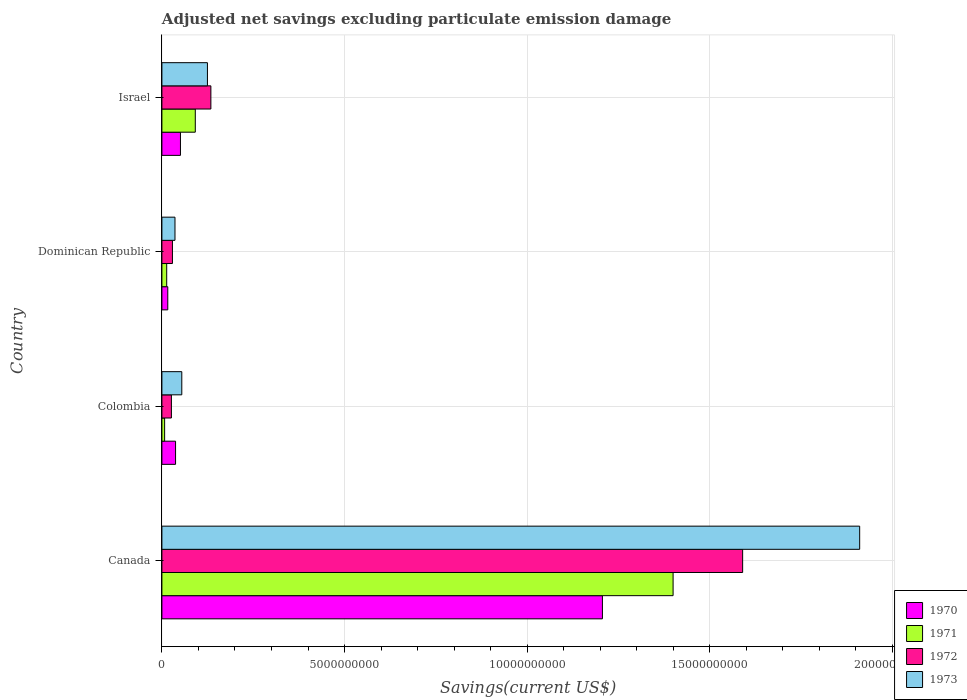How many groups of bars are there?
Provide a succinct answer. 4. Are the number of bars per tick equal to the number of legend labels?
Your answer should be compact. Yes. How many bars are there on the 4th tick from the top?
Offer a very short reply. 4. What is the label of the 2nd group of bars from the top?
Your answer should be compact. Dominican Republic. What is the adjusted net savings in 1971 in Dominican Republic?
Make the answer very short. 1.32e+08. Across all countries, what is the maximum adjusted net savings in 1970?
Provide a short and direct response. 1.21e+1. Across all countries, what is the minimum adjusted net savings in 1972?
Your answer should be very brief. 2.60e+08. In which country was the adjusted net savings in 1970 maximum?
Your response must be concise. Canada. In which country was the adjusted net savings in 1970 minimum?
Provide a succinct answer. Dominican Republic. What is the total adjusted net savings in 1970 in the graph?
Your answer should be very brief. 1.31e+1. What is the difference between the adjusted net savings in 1971 in Colombia and that in Dominican Republic?
Keep it short and to the point. -5.69e+07. What is the difference between the adjusted net savings in 1973 in Dominican Republic and the adjusted net savings in 1972 in Colombia?
Provide a succinct answer. 9.79e+07. What is the average adjusted net savings in 1972 per country?
Offer a very short reply. 4.45e+09. What is the difference between the adjusted net savings in 1970 and adjusted net savings in 1973 in Dominican Republic?
Your answer should be very brief. -1.97e+08. What is the ratio of the adjusted net savings in 1972 in Canada to that in Dominican Republic?
Your answer should be very brief. 55.08. What is the difference between the highest and the second highest adjusted net savings in 1970?
Give a very brief answer. 1.16e+1. What is the difference between the highest and the lowest adjusted net savings in 1970?
Provide a short and direct response. 1.19e+1. Is the sum of the adjusted net savings in 1971 in Colombia and Israel greater than the maximum adjusted net savings in 1972 across all countries?
Your answer should be compact. No. What does the 3rd bar from the top in Canada represents?
Keep it short and to the point. 1971. Is it the case that in every country, the sum of the adjusted net savings in 1973 and adjusted net savings in 1972 is greater than the adjusted net savings in 1971?
Your response must be concise. Yes. How many bars are there?
Make the answer very short. 16. Are the values on the major ticks of X-axis written in scientific E-notation?
Your answer should be very brief. No. Does the graph contain any zero values?
Provide a short and direct response. No. How many legend labels are there?
Provide a succinct answer. 4. What is the title of the graph?
Offer a very short reply. Adjusted net savings excluding particulate emission damage. What is the label or title of the X-axis?
Your answer should be compact. Savings(current US$). What is the label or title of the Y-axis?
Provide a succinct answer. Country. What is the Savings(current US$) of 1970 in Canada?
Provide a succinct answer. 1.21e+1. What is the Savings(current US$) of 1971 in Canada?
Your answer should be compact. 1.40e+1. What is the Savings(current US$) of 1972 in Canada?
Make the answer very short. 1.59e+1. What is the Savings(current US$) of 1973 in Canada?
Keep it short and to the point. 1.91e+1. What is the Savings(current US$) of 1970 in Colombia?
Your response must be concise. 3.74e+08. What is the Savings(current US$) of 1971 in Colombia?
Provide a succinct answer. 7.46e+07. What is the Savings(current US$) of 1972 in Colombia?
Your answer should be very brief. 2.60e+08. What is the Savings(current US$) in 1973 in Colombia?
Your answer should be very brief. 5.45e+08. What is the Savings(current US$) of 1970 in Dominican Republic?
Your response must be concise. 1.61e+08. What is the Savings(current US$) in 1971 in Dominican Republic?
Your response must be concise. 1.32e+08. What is the Savings(current US$) in 1972 in Dominican Republic?
Provide a short and direct response. 2.89e+08. What is the Savings(current US$) of 1973 in Dominican Republic?
Give a very brief answer. 3.58e+08. What is the Savings(current US$) of 1970 in Israel?
Provide a short and direct response. 5.08e+08. What is the Savings(current US$) of 1971 in Israel?
Offer a very short reply. 9.14e+08. What is the Savings(current US$) in 1972 in Israel?
Offer a terse response. 1.34e+09. What is the Savings(current US$) in 1973 in Israel?
Make the answer very short. 1.25e+09. Across all countries, what is the maximum Savings(current US$) in 1970?
Your answer should be very brief. 1.21e+1. Across all countries, what is the maximum Savings(current US$) in 1971?
Provide a short and direct response. 1.40e+1. Across all countries, what is the maximum Savings(current US$) of 1972?
Provide a succinct answer. 1.59e+1. Across all countries, what is the maximum Savings(current US$) in 1973?
Your answer should be compact. 1.91e+1. Across all countries, what is the minimum Savings(current US$) in 1970?
Make the answer very short. 1.61e+08. Across all countries, what is the minimum Savings(current US$) of 1971?
Make the answer very short. 7.46e+07. Across all countries, what is the minimum Savings(current US$) of 1972?
Your answer should be very brief. 2.60e+08. Across all countries, what is the minimum Savings(current US$) in 1973?
Provide a short and direct response. 3.58e+08. What is the total Savings(current US$) in 1970 in the graph?
Your response must be concise. 1.31e+1. What is the total Savings(current US$) in 1971 in the graph?
Provide a succinct answer. 1.51e+1. What is the total Savings(current US$) of 1972 in the graph?
Provide a succinct answer. 1.78e+1. What is the total Savings(current US$) of 1973 in the graph?
Provide a succinct answer. 2.13e+1. What is the difference between the Savings(current US$) of 1970 in Canada and that in Colombia?
Offer a terse response. 1.17e+1. What is the difference between the Savings(current US$) in 1971 in Canada and that in Colombia?
Offer a terse response. 1.39e+1. What is the difference between the Savings(current US$) of 1972 in Canada and that in Colombia?
Your response must be concise. 1.56e+1. What is the difference between the Savings(current US$) of 1973 in Canada and that in Colombia?
Offer a very short reply. 1.86e+1. What is the difference between the Savings(current US$) of 1970 in Canada and that in Dominican Republic?
Provide a short and direct response. 1.19e+1. What is the difference between the Savings(current US$) of 1971 in Canada and that in Dominican Republic?
Offer a terse response. 1.39e+1. What is the difference between the Savings(current US$) in 1972 in Canada and that in Dominican Republic?
Your answer should be very brief. 1.56e+1. What is the difference between the Savings(current US$) of 1973 in Canada and that in Dominican Republic?
Your answer should be compact. 1.87e+1. What is the difference between the Savings(current US$) in 1970 in Canada and that in Israel?
Provide a succinct answer. 1.16e+1. What is the difference between the Savings(current US$) of 1971 in Canada and that in Israel?
Give a very brief answer. 1.31e+1. What is the difference between the Savings(current US$) of 1972 in Canada and that in Israel?
Your answer should be compact. 1.46e+1. What is the difference between the Savings(current US$) of 1973 in Canada and that in Israel?
Offer a very short reply. 1.79e+1. What is the difference between the Savings(current US$) of 1970 in Colombia and that in Dominican Republic?
Make the answer very short. 2.13e+08. What is the difference between the Savings(current US$) in 1971 in Colombia and that in Dominican Republic?
Ensure brevity in your answer.  -5.69e+07. What is the difference between the Savings(current US$) of 1972 in Colombia and that in Dominican Republic?
Your answer should be very brief. -2.84e+07. What is the difference between the Savings(current US$) of 1973 in Colombia and that in Dominican Republic?
Your answer should be compact. 1.87e+08. What is the difference between the Savings(current US$) of 1970 in Colombia and that in Israel?
Ensure brevity in your answer.  -1.34e+08. What is the difference between the Savings(current US$) in 1971 in Colombia and that in Israel?
Provide a succinct answer. -8.40e+08. What is the difference between the Savings(current US$) of 1972 in Colombia and that in Israel?
Your answer should be very brief. -1.08e+09. What is the difference between the Savings(current US$) of 1973 in Colombia and that in Israel?
Offer a very short reply. -7.02e+08. What is the difference between the Savings(current US$) in 1970 in Dominican Republic and that in Israel?
Ensure brevity in your answer.  -3.47e+08. What is the difference between the Savings(current US$) in 1971 in Dominican Republic and that in Israel?
Your answer should be very brief. -7.83e+08. What is the difference between the Savings(current US$) of 1972 in Dominican Republic and that in Israel?
Ensure brevity in your answer.  -1.05e+09. What is the difference between the Savings(current US$) of 1973 in Dominican Republic and that in Israel?
Keep it short and to the point. -8.89e+08. What is the difference between the Savings(current US$) in 1970 in Canada and the Savings(current US$) in 1971 in Colombia?
Ensure brevity in your answer.  1.20e+1. What is the difference between the Savings(current US$) in 1970 in Canada and the Savings(current US$) in 1972 in Colombia?
Offer a terse response. 1.18e+1. What is the difference between the Savings(current US$) in 1970 in Canada and the Savings(current US$) in 1973 in Colombia?
Your answer should be very brief. 1.15e+1. What is the difference between the Savings(current US$) of 1971 in Canada and the Savings(current US$) of 1972 in Colombia?
Keep it short and to the point. 1.37e+1. What is the difference between the Savings(current US$) of 1971 in Canada and the Savings(current US$) of 1973 in Colombia?
Your answer should be compact. 1.35e+1. What is the difference between the Savings(current US$) in 1972 in Canada and the Savings(current US$) in 1973 in Colombia?
Provide a short and direct response. 1.54e+1. What is the difference between the Savings(current US$) in 1970 in Canada and the Savings(current US$) in 1971 in Dominican Republic?
Give a very brief answer. 1.19e+1. What is the difference between the Savings(current US$) in 1970 in Canada and the Savings(current US$) in 1972 in Dominican Republic?
Make the answer very short. 1.18e+1. What is the difference between the Savings(current US$) of 1970 in Canada and the Savings(current US$) of 1973 in Dominican Republic?
Provide a short and direct response. 1.17e+1. What is the difference between the Savings(current US$) of 1971 in Canada and the Savings(current US$) of 1972 in Dominican Republic?
Ensure brevity in your answer.  1.37e+1. What is the difference between the Savings(current US$) in 1971 in Canada and the Savings(current US$) in 1973 in Dominican Republic?
Give a very brief answer. 1.36e+1. What is the difference between the Savings(current US$) in 1972 in Canada and the Savings(current US$) in 1973 in Dominican Republic?
Offer a very short reply. 1.55e+1. What is the difference between the Savings(current US$) of 1970 in Canada and the Savings(current US$) of 1971 in Israel?
Your answer should be compact. 1.11e+1. What is the difference between the Savings(current US$) in 1970 in Canada and the Savings(current US$) in 1972 in Israel?
Ensure brevity in your answer.  1.07e+1. What is the difference between the Savings(current US$) of 1970 in Canada and the Savings(current US$) of 1973 in Israel?
Provide a succinct answer. 1.08e+1. What is the difference between the Savings(current US$) in 1971 in Canada and the Savings(current US$) in 1972 in Israel?
Provide a short and direct response. 1.27e+1. What is the difference between the Savings(current US$) of 1971 in Canada and the Savings(current US$) of 1973 in Israel?
Provide a short and direct response. 1.27e+1. What is the difference between the Savings(current US$) in 1972 in Canada and the Savings(current US$) in 1973 in Israel?
Give a very brief answer. 1.47e+1. What is the difference between the Savings(current US$) in 1970 in Colombia and the Savings(current US$) in 1971 in Dominican Republic?
Your answer should be compact. 2.42e+08. What is the difference between the Savings(current US$) of 1970 in Colombia and the Savings(current US$) of 1972 in Dominican Republic?
Your answer should be compact. 8.52e+07. What is the difference between the Savings(current US$) of 1970 in Colombia and the Savings(current US$) of 1973 in Dominican Republic?
Ensure brevity in your answer.  1.57e+07. What is the difference between the Savings(current US$) of 1971 in Colombia and the Savings(current US$) of 1972 in Dominican Republic?
Offer a terse response. -2.14e+08. What is the difference between the Savings(current US$) in 1971 in Colombia and the Savings(current US$) in 1973 in Dominican Republic?
Make the answer very short. -2.84e+08. What is the difference between the Savings(current US$) of 1972 in Colombia and the Savings(current US$) of 1973 in Dominican Republic?
Make the answer very short. -9.79e+07. What is the difference between the Savings(current US$) in 1970 in Colombia and the Savings(current US$) in 1971 in Israel?
Give a very brief answer. -5.40e+08. What is the difference between the Savings(current US$) of 1970 in Colombia and the Savings(current US$) of 1972 in Israel?
Provide a succinct answer. -9.67e+08. What is the difference between the Savings(current US$) in 1970 in Colombia and the Savings(current US$) in 1973 in Israel?
Ensure brevity in your answer.  -8.73e+08. What is the difference between the Savings(current US$) in 1971 in Colombia and the Savings(current US$) in 1972 in Israel?
Provide a short and direct response. -1.27e+09. What is the difference between the Savings(current US$) in 1971 in Colombia and the Savings(current US$) in 1973 in Israel?
Ensure brevity in your answer.  -1.17e+09. What is the difference between the Savings(current US$) of 1972 in Colombia and the Savings(current US$) of 1973 in Israel?
Make the answer very short. -9.87e+08. What is the difference between the Savings(current US$) of 1970 in Dominican Republic and the Savings(current US$) of 1971 in Israel?
Make the answer very short. -7.53e+08. What is the difference between the Savings(current US$) in 1970 in Dominican Republic and the Savings(current US$) in 1972 in Israel?
Offer a terse response. -1.18e+09. What is the difference between the Savings(current US$) in 1970 in Dominican Republic and the Savings(current US$) in 1973 in Israel?
Make the answer very short. -1.09e+09. What is the difference between the Savings(current US$) in 1971 in Dominican Republic and the Savings(current US$) in 1972 in Israel?
Your answer should be very brief. -1.21e+09. What is the difference between the Savings(current US$) in 1971 in Dominican Republic and the Savings(current US$) in 1973 in Israel?
Your answer should be compact. -1.12e+09. What is the difference between the Savings(current US$) of 1972 in Dominican Republic and the Savings(current US$) of 1973 in Israel?
Keep it short and to the point. -9.58e+08. What is the average Savings(current US$) in 1970 per country?
Your answer should be compact. 3.28e+09. What is the average Savings(current US$) in 1971 per country?
Your answer should be compact. 3.78e+09. What is the average Savings(current US$) in 1972 per country?
Offer a very short reply. 4.45e+09. What is the average Savings(current US$) in 1973 per country?
Your response must be concise. 5.31e+09. What is the difference between the Savings(current US$) in 1970 and Savings(current US$) in 1971 in Canada?
Offer a very short reply. -1.94e+09. What is the difference between the Savings(current US$) in 1970 and Savings(current US$) in 1972 in Canada?
Make the answer very short. -3.84e+09. What is the difference between the Savings(current US$) of 1970 and Savings(current US$) of 1973 in Canada?
Your answer should be compact. -7.04e+09. What is the difference between the Savings(current US$) in 1971 and Savings(current US$) in 1972 in Canada?
Provide a succinct answer. -1.90e+09. What is the difference between the Savings(current US$) of 1971 and Savings(current US$) of 1973 in Canada?
Provide a succinct answer. -5.11e+09. What is the difference between the Savings(current US$) of 1972 and Savings(current US$) of 1973 in Canada?
Ensure brevity in your answer.  -3.20e+09. What is the difference between the Savings(current US$) of 1970 and Savings(current US$) of 1971 in Colombia?
Ensure brevity in your answer.  2.99e+08. What is the difference between the Savings(current US$) in 1970 and Savings(current US$) in 1972 in Colombia?
Provide a short and direct response. 1.14e+08. What is the difference between the Savings(current US$) in 1970 and Savings(current US$) in 1973 in Colombia?
Your answer should be compact. -1.71e+08. What is the difference between the Savings(current US$) of 1971 and Savings(current US$) of 1972 in Colombia?
Give a very brief answer. -1.86e+08. What is the difference between the Savings(current US$) of 1971 and Savings(current US$) of 1973 in Colombia?
Ensure brevity in your answer.  -4.70e+08. What is the difference between the Savings(current US$) of 1972 and Savings(current US$) of 1973 in Colombia?
Provide a succinct answer. -2.85e+08. What is the difference between the Savings(current US$) of 1970 and Savings(current US$) of 1971 in Dominican Republic?
Keep it short and to the point. 2.96e+07. What is the difference between the Savings(current US$) in 1970 and Savings(current US$) in 1972 in Dominican Republic?
Provide a short and direct response. -1.28e+08. What is the difference between the Savings(current US$) in 1970 and Savings(current US$) in 1973 in Dominican Republic?
Offer a very short reply. -1.97e+08. What is the difference between the Savings(current US$) of 1971 and Savings(current US$) of 1972 in Dominican Republic?
Your answer should be compact. -1.57e+08. What is the difference between the Savings(current US$) of 1971 and Savings(current US$) of 1973 in Dominican Republic?
Provide a succinct answer. -2.27e+08. What is the difference between the Savings(current US$) of 1972 and Savings(current US$) of 1973 in Dominican Republic?
Offer a very short reply. -6.95e+07. What is the difference between the Savings(current US$) of 1970 and Savings(current US$) of 1971 in Israel?
Provide a succinct answer. -4.06e+08. What is the difference between the Savings(current US$) of 1970 and Savings(current US$) of 1972 in Israel?
Provide a short and direct response. -8.33e+08. What is the difference between the Savings(current US$) of 1970 and Savings(current US$) of 1973 in Israel?
Your answer should be very brief. -7.39e+08. What is the difference between the Savings(current US$) of 1971 and Savings(current US$) of 1972 in Israel?
Offer a terse response. -4.27e+08. What is the difference between the Savings(current US$) in 1971 and Savings(current US$) in 1973 in Israel?
Ensure brevity in your answer.  -3.33e+08. What is the difference between the Savings(current US$) of 1972 and Savings(current US$) of 1973 in Israel?
Your response must be concise. 9.40e+07. What is the ratio of the Savings(current US$) of 1970 in Canada to that in Colombia?
Ensure brevity in your answer.  32.26. What is the ratio of the Savings(current US$) in 1971 in Canada to that in Colombia?
Offer a terse response. 187.59. What is the ratio of the Savings(current US$) in 1972 in Canada to that in Colombia?
Provide a short and direct response. 61.09. What is the ratio of the Savings(current US$) of 1973 in Canada to that in Colombia?
Offer a terse response. 35.07. What is the ratio of the Savings(current US$) of 1970 in Canada to that in Dominican Republic?
Offer a terse response. 74.87. What is the ratio of the Savings(current US$) of 1971 in Canada to that in Dominican Republic?
Provide a short and direct response. 106.4. What is the ratio of the Savings(current US$) of 1972 in Canada to that in Dominican Republic?
Provide a succinct answer. 55.08. What is the ratio of the Savings(current US$) of 1973 in Canada to that in Dominican Republic?
Your response must be concise. 53.33. What is the ratio of the Savings(current US$) of 1970 in Canada to that in Israel?
Keep it short and to the point. 23.75. What is the ratio of the Savings(current US$) in 1971 in Canada to that in Israel?
Offer a very short reply. 15.31. What is the ratio of the Savings(current US$) in 1972 in Canada to that in Israel?
Provide a succinct answer. 11.86. What is the ratio of the Savings(current US$) in 1973 in Canada to that in Israel?
Offer a very short reply. 15.32. What is the ratio of the Savings(current US$) of 1970 in Colombia to that in Dominican Republic?
Keep it short and to the point. 2.32. What is the ratio of the Savings(current US$) in 1971 in Colombia to that in Dominican Republic?
Your answer should be very brief. 0.57. What is the ratio of the Savings(current US$) of 1972 in Colombia to that in Dominican Republic?
Your response must be concise. 0.9. What is the ratio of the Savings(current US$) in 1973 in Colombia to that in Dominican Republic?
Your answer should be very brief. 1.52. What is the ratio of the Savings(current US$) of 1970 in Colombia to that in Israel?
Offer a very short reply. 0.74. What is the ratio of the Savings(current US$) in 1971 in Colombia to that in Israel?
Keep it short and to the point. 0.08. What is the ratio of the Savings(current US$) of 1972 in Colombia to that in Israel?
Your answer should be very brief. 0.19. What is the ratio of the Savings(current US$) of 1973 in Colombia to that in Israel?
Offer a terse response. 0.44. What is the ratio of the Savings(current US$) of 1970 in Dominican Republic to that in Israel?
Provide a short and direct response. 0.32. What is the ratio of the Savings(current US$) of 1971 in Dominican Republic to that in Israel?
Your answer should be compact. 0.14. What is the ratio of the Savings(current US$) in 1972 in Dominican Republic to that in Israel?
Your answer should be compact. 0.22. What is the ratio of the Savings(current US$) of 1973 in Dominican Republic to that in Israel?
Offer a terse response. 0.29. What is the difference between the highest and the second highest Savings(current US$) in 1970?
Ensure brevity in your answer.  1.16e+1. What is the difference between the highest and the second highest Savings(current US$) in 1971?
Make the answer very short. 1.31e+1. What is the difference between the highest and the second highest Savings(current US$) in 1972?
Provide a succinct answer. 1.46e+1. What is the difference between the highest and the second highest Savings(current US$) of 1973?
Your response must be concise. 1.79e+1. What is the difference between the highest and the lowest Savings(current US$) in 1970?
Ensure brevity in your answer.  1.19e+1. What is the difference between the highest and the lowest Savings(current US$) of 1971?
Provide a succinct answer. 1.39e+1. What is the difference between the highest and the lowest Savings(current US$) in 1972?
Your response must be concise. 1.56e+1. What is the difference between the highest and the lowest Savings(current US$) of 1973?
Ensure brevity in your answer.  1.87e+1. 